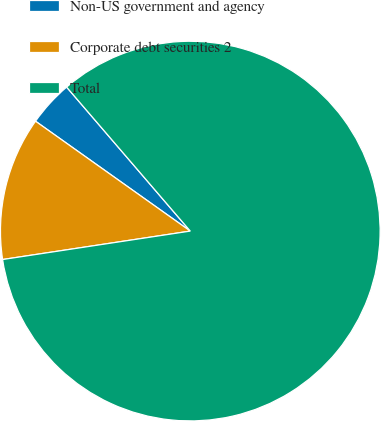Convert chart to OTSL. <chart><loc_0><loc_0><loc_500><loc_500><pie_chart><fcel>Non-US government and agency<fcel>Corporate debt securities 2<fcel>Total<nl><fcel>3.88%<fcel>12.22%<fcel>83.9%<nl></chart> 